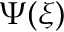<formula> <loc_0><loc_0><loc_500><loc_500>\Psi ( \xi )</formula> 